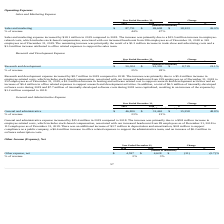According to Everbridge's financial document, What was the increase in the General and administrative expense in 2019? According to the financial document, $15.4 million. The relevant text states: "General and administrative expense increased by $15.4 million in 2019 compared to 2018. The increase was primarily due to a $9.8 million increase in employee-rela..." Also, What was the increase in the cost of depreciation and amortization from 2018 to 2019? According to the financial document, $3.7 million. The relevant text states: "mber 31, 2019. There was an additional increase of $3.7 million in depreciation and amortization, $0.8 million to support compliance as a public company, a $0.6 mil..." Also, What was the % of revenue for General and administrative expense in 2019 and 2018? The document shows two values: 23 and 21 (percentage). From the document: "% of revenue 23% 21% % of revenue 23% 21%..." Also, can you calculate: What was the average General and administrative expense for 2018 and 2019? To answer this question, I need to perform calculations using the financial data. The calculation is: (46,820 + 31,462) / 2, which equals 39141 (in thousands). This is based on the information: "General and administrative $ 46,820 $ 31,462 $ 15,358 48.8% General and administrative $ 46,820 $ 31,462 $ 15,358 48.8%..." The key data points involved are: 31,462, 46,820. Additionally, In which year was General and administrative expenses less than 50,000 thousands? The document shows two values: 2019 and 2018. Locate and analyze general and administrative in row 4. From the document: "2019 2018 $ % 2019 2018 $ %..." Also, can you calculate: What is the change in the % of revenue from 2018 to 2019? Based on the calculation: 23 - 21, the result is 2 (percentage). This is based on the information: "% of revenue 23% 21% % of revenue 23% 21%..." The key data points involved are: 21, 23. 